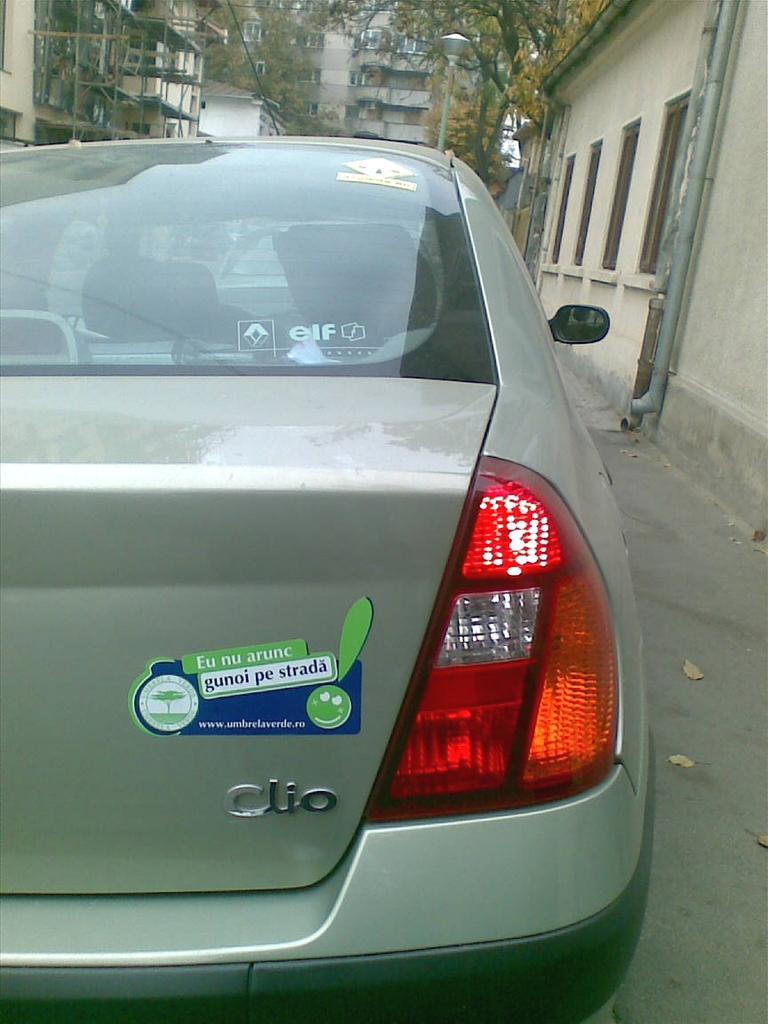Could you give a brief overview of what you see in this image? In this image, we can see a vehicle. Here we can see glass and side mirror. Through the glass we can see the inside and out side view. Here there is another vehicle and seats we can see. At the background and right side of the image, we can see few buildings, houses, trees. Here we can see few pipes and footpath. 